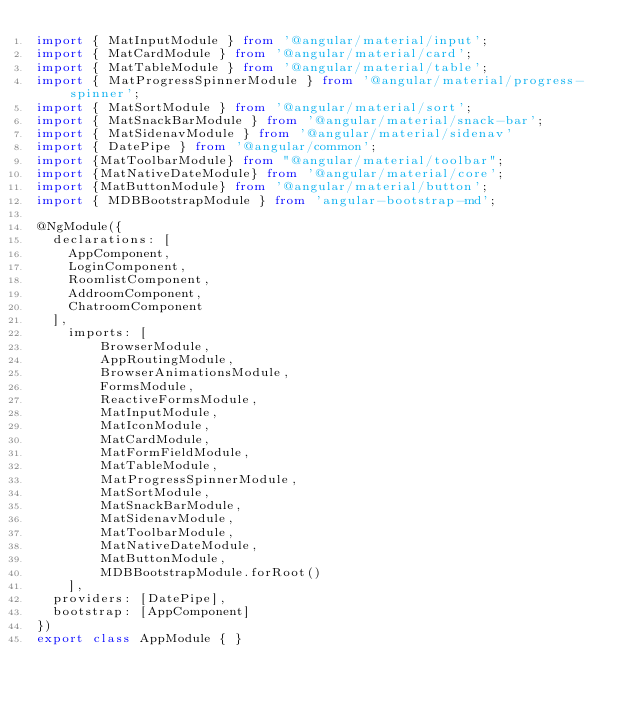Convert code to text. <code><loc_0><loc_0><loc_500><loc_500><_TypeScript_>import { MatInputModule } from '@angular/material/input';
import { MatCardModule } from '@angular/material/card';
import { MatTableModule } from '@angular/material/table';
import { MatProgressSpinnerModule } from '@angular/material/progress-spinner';
import { MatSortModule } from '@angular/material/sort';
import { MatSnackBarModule } from '@angular/material/snack-bar';
import { MatSidenavModule } from '@angular/material/sidenav'
import { DatePipe } from '@angular/common';
import {MatToolbarModule} from "@angular/material/toolbar";
import {MatNativeDateModule} from '@angular/material/core';
import {MatButtonModule} from '@angular/material/button';
import { MDBBootstrapModule } from 'angular-bootstrap-md';

@NgModule({
  declarations: [
    AppComponent,
    LoginComponent,
    RoomlistComponent,
    AddroomComponent,
    ChatroomComponent
  ],
    imports: [
        BrowserModule,
        AppRoutingModule,
        BrowserAnimationsModule,
        FormsModule,
        ReactiveFormsModule,
        MatInputModule,
        MatIconModule,
        MatCardModule,
        MatFormFieldModule,
        MatTableModule,
        MatProgressSpinnerModule,
        MatSortModule,
        MatSnackBarModule,
        MatSidenavModule,
        MatToolbarModule,
        MatNativeDateModule,
        MatButtonModule,
        MDBBootstrapModule.forRoot()
    ],
  providers: [DatePipe],
  bootstrap: [AppComponent]
})
export class AppModule { }
</code> 